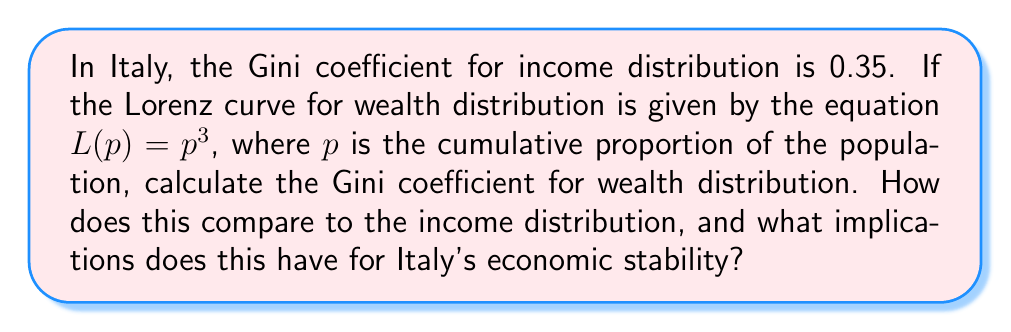Teach me how to tackle this problem. To solve this problem, we'll follow these steps:

1) The Gini coefficient is calculated as twice the area between the Lorenz curve and the line of perfect equality (45-degree line).

2) The area under the line of perfect equality is always 0.5.

3) To find the area under the Lorenz curve, we integrate $L(p)$ from 0 to 1:

   $$\int_0^1 L(p) dp = \int_0^1 p^3 dp = \left[\frac{p^4}{4}\right]_0^1 = \frac{1}{4}$$

4) The area between the Lorenz curve and the line of perfect equality is:

   $$0.5 - 0.25 = 0.25$$

5) The Gini coefficient is twice this area:

   $$G = 2 * 0.25 = 0.5$$

6) Comparing to the income Gini coefficient:
   - Wealth Gini: 0.5
   - Income Gini: 0.35

The wealth distribution (0.5) is more unequal than the income distribution (0.35). This larger disparity in wealth could lead to increased economic instability, as it may result in reduced social mobility, increased political polarization, and potentially slower economic growth. For Italy's economic stability, this suggests a need for policies that address wealth inequality, such as progressive taxation or wealth redistribution measures.
Answer: Wealth Gini coefficient: 0.5. This indicates greater inequality in wealth distribution compared to income distribution (0.35), potentially threatening Italy's economic stability. 